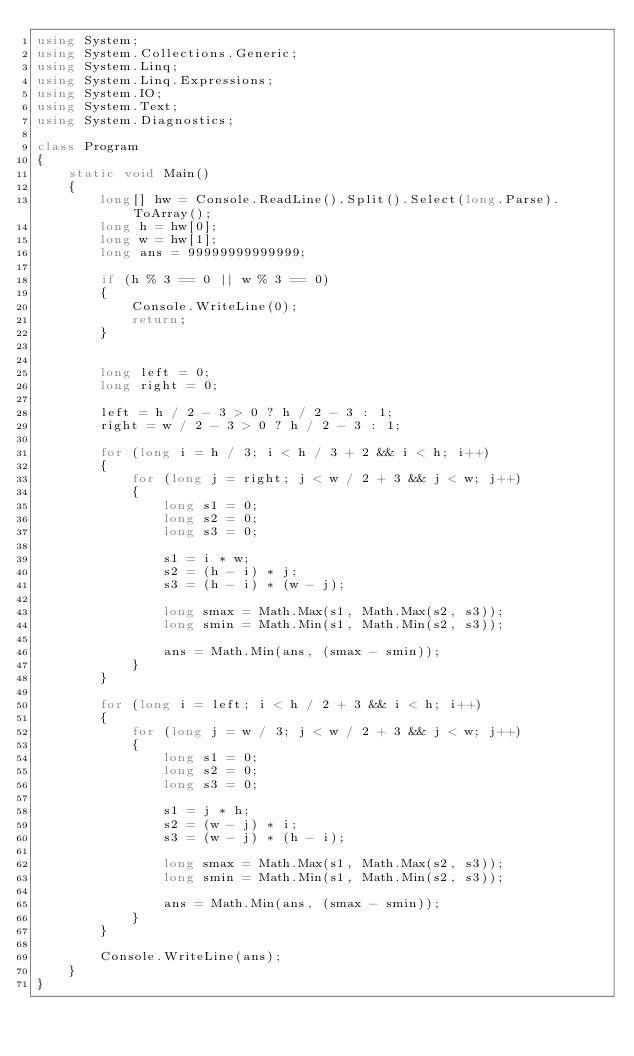Convert code to text. <code><loc_0><loc_0><loc_500><loc_500><_C#_>using System;
using System.Collections.Generic;
using System.Linq;
using System.Linq.Expressions;
using System.IO;
using System.Text;
using System.Diagnostics;

class Program
{
    static void Main()
    {
        long[] hw = Console.ReadLine().Split().Select(long.Parse).ToArray();
        long h = hw[0];
        long w = hw[1];
        long ans = 99999999999999;

        if (h % 3 == 0 || w % 3 == 0)
        {
            Console.WriteLine(0);
            return;
        }


        long left = 0;
        long right = 0;

        left = h / 2 - 3 > 0 ? h / 2 - 3 : 1;
        right = w / 2 - 3 > 0 ? h / 2 - 3 : 1;

        for (long i = h / 3; i < h / 3 + 2 && i < h; i++)
        {
            for (long j = right; j < w / 2 + 3 && j < w; j++)
            {
                long s1 = 0;
                long s2 = 0;
                long s3 = 0;

                s1 = i * w;
                s2 = (h - i) * j;
                s3 = (h - i) * (w - j);

                long smax = Math.Max(s1, Math.Max(s2, s3));
                long smin = Math.Min(s1, Math.Min(s2, s3));

                ans = Math.Min(ans, (smax - smin));
            }
        }

        for (long i = left; i < h / 2 + 3 && i < h; i++)
        {
            for (long j = w / 3; j < w / 2 + 3 && j < w; j++)
            {
                long s1 = 0;
                long s2 = 0;
                long s3 = 0;

                s1 = j * h;
                s2 = (w - j) * i;
                s3 = (w - j) * (h - i);

                long smax = Math.Max(s1, Math.Max(s2, s3));
                long smin = Math.Min(s1, Math.Min(s2, s3));

                ans = Math.Min(ans, (smax - smin));
            }
        }

        Console.WriteLine(ans);
    }
}</code> 